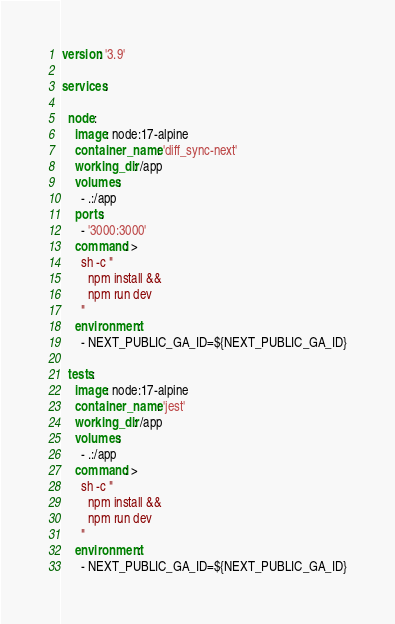Convert code to text. <code><loc_0><loc_0><loc_500><loc_500><_YAML_>version: '3.9'

services:

  node:
    image: node:17-alpine
    container_name: 'diff_sync-next'
    working_dir: /app
    volumes:
      - .:/app
    ports:
      - '3000:3000'
    command: >
      sh -c "
        npm install &&
        npm run dev
      "
    environment:
      - NEXT_PUBLIC_GA_ID=${NEXT_PUBLIC_GA_ID}

  tests:
    image: node:17-alpine
    container_name: 'jest'
    working_dir: /app
    volumes:
      - .:/app
    command: >
      sh -c "
        npm install &&
        npm run dev
      "
    environment:
      - NEXT_PUBLIC_GA_ID=${NEXT_PUBLIC_GA_ID}
</code> 